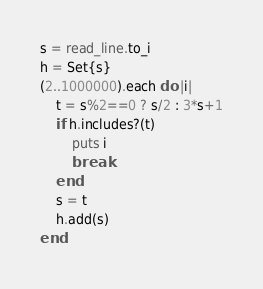Convert code to text. <code><loc_0><loc_0><loc_500><loc_500><_Crystal_>s = read_line.to_i
h = Set{s}
(2..1000000).each do |i|
    t = s%2==0 ? s/2 : 3*s+1
    if h.includes?(t)
        puts i
        break
    end
    s = t
    h.add(s)
end</code> 